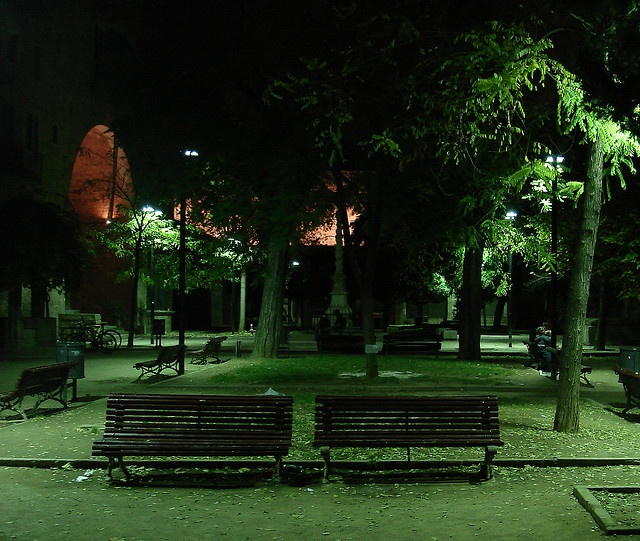Describe the objects in this image and their specific colors. I can see bench in black and darkgreen tones, bench in black and darkgreen tones, bench in black and darkgreen tones, bench in black, darkgreen, teal, and green tones, and bench in black tones in this image. 